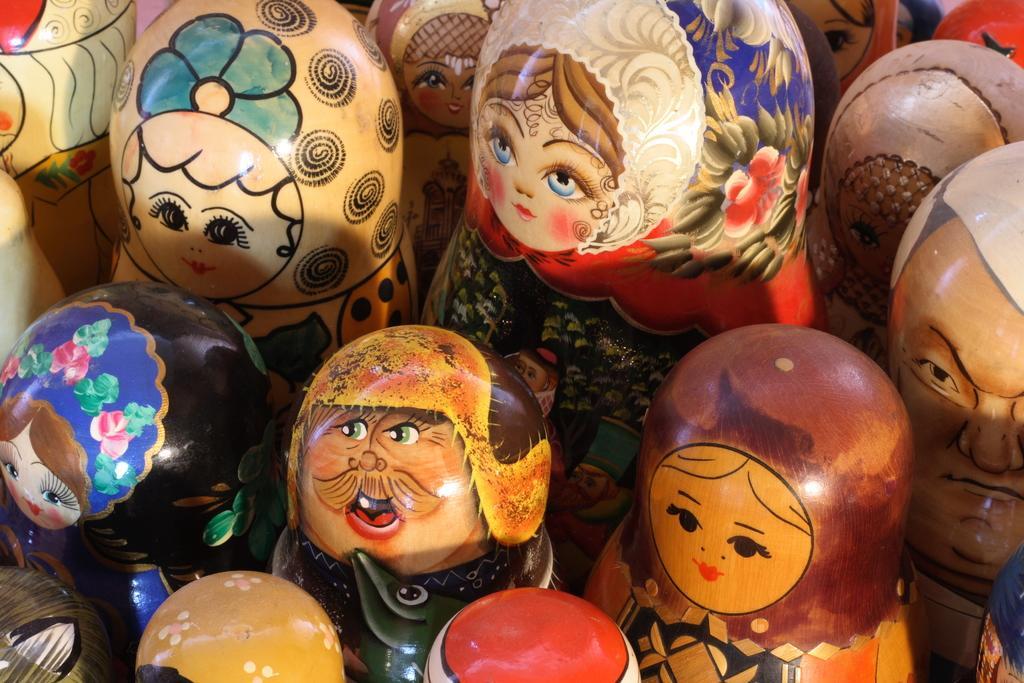Can you describe this image briefly? In this image there are a group of objects, and on the objects there is some art. 